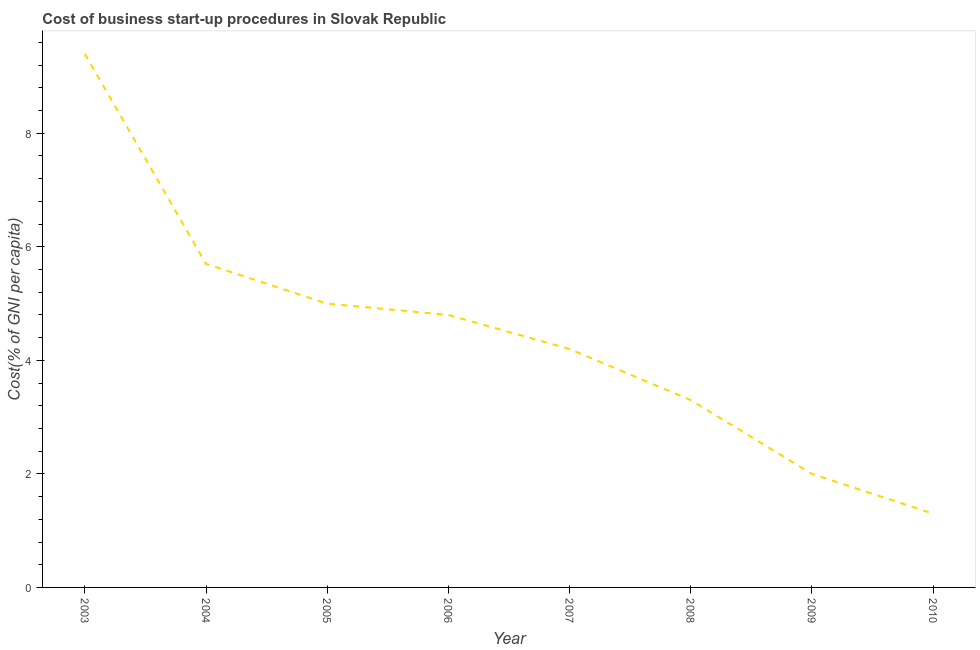What is the cost of business startup procedures in 2005?
Provide a short and direct response. 5. Across all years, what is the maximum cost of business startup procedures?
Give a very brief answer. 9.4. What is the sum of the cost of business startup procedures?
Keep it short and to the point. 35.7. What is the difference between the cost of business startup procedures in 2003 and 2008?
Your answer should be compact. 6.1. What is the average cost of business startup procedures per year?
Ensure brevity in your answer.  4.46. Do a majority of the years between 2009 and 2006 (inclusive) have cost of business startup procedures greater than 6 %?
Your response must be concise. Yes. What is the ratio of the cost of business startup procedures in 2005 to that in 2007?
Your response must be concise. 1.19. What is the difference between the highest and the lowest cost of business startup procedures?
Give a very brief answer. 8.1. How many lines are there?
Keep it short and to the point. 1. What is the title of the graph?
Provide a succinct answer. Cost of business start-up procedures in Slovak Republic. What is the label or title of the Y-axis?
Ensure brevity in your answer.  Cost(% of GNI per capita). What is the Cost(% of GNI per capita) of 2003?
Provide a short and direct response. 9.4. What is the Cost(% of GNI per capita) of 2009?
Provide a succinct answer. 2. What is the Cost(% of GNI per capita) of 2010?
Offer a very short reply. 1.3. What is the difference between the Cost(% of GNI per capita) in 2003 and 2006?
Your response must be concise. 4.6. What is the difference between the Cost(% of GNI per capita) in 2003 and 2007?
Provide a short and direct response. 5.2. What is the difference between the Cost(% of GNI per capita) in 2003 and 2010?
Provide a short and direct response. 8.1. What is the difference between the Cost(% of GNI per capita) in 2004 and 2005?
Offer a very short reply. 0.7. What is the difference between the Cost(% of GNI per capita) in 2004 and 2008?
Ensure brevity in your answer.  2.4. What is the difference between the Cost(% of GNI per capita) in 2005 and 2006?
Keep it short and to the point. 0.2. What is the difference between the Cost(% of GNI per capita) in 2005 and 2008?
Your answer should be compact. 1.7. What is the difference between the Cost(% of GNI per capita) in 2006 and 2009?
Offer a terse response. 2.8. What is the difference between the Cost(% of GNI per capita) in 2007 and 2008?
Give a very brief answer. 0.9. What is the difference between the Cost(% of GNI per capita) in 2007 and 2009?
Offer a very short reply. 2.2. What is the difference between the Cost(% of GNI per capita) in 2009 and 2010?
Provide a succinct answer. 0.7. What is the ratio of the Cost(% of GNI per capita) in 2003 to that in 2004?
Make the answer very short. 1.65. What is the ratio of the Cost(% of GNI per capita) in 2003 to that in 2005?
Provide a succinct answer. 1.88. What is the ratio of the Cost(% of GNI per capita) in 2003 to that in 2006?
Give a very brief answer. 1.96. What is the ratio of the Cost(% of GNI per capita) in 2003 to that in 2007?
Your answer should be compact. 2.24. What is the ratio of the Cost(% of GNI per capita) in 2003 to that in 2008?
Keep it short and to the point. 2.85. What is the ratio of the Cost(% of GNI per capita) in 2003 to that in 2010?
Make the answer very short. 7.23. What is the ratio of the Cost(% of GNI per capita) in 2004 to that in 2005?
Keep it short and to the point. 1.14. What is the ratio of the Cost(% of GNI per capita) in 2004 to that in 2006?
Make the answer very short. 1.19. What is the ratio of the Cost(% of GNI per capita) in 2004 to that in 2007?
Make the answer very short. 1.36. What is the ratio of the Cost(% of GNI per capita) in 2004 to that in 2008?
Offer a very short reply. 1.73. What is the ratio of the Cost(% of GNI per capita) in 2004 to that in 2009?
Your response must be concise. 2.85. What is the ratio of the Cost(% of GNI per capita) in 2004 to that in 2010?
Provide a short and direct response. 4.38. What is the ratio of the Cost(% of GNI per capita) in 2005 to that in 2006?
Give a very brief answer. 1.04. What is the ratio of the Cost(% of GNI per capita) in 2005 to that in 2007?
Give a very brief answer. 1.19. What is the ratio of the Cost(% of GNI per capita) in 2005 to that in 2008?
Give a very brief answer. 1.51. What is the ratio of the Cost(% of GNI per capita) in 2005 to that in 2009?
Your answer should be compact. 2.5. What is the ratio of the Cost(% of GNI per capita) in 2005 to that in 2010?
Provide a succinct answer. 3.85. What is the ratio of the Cost(% of GNI per capita) in 2006 to that in 2007?
Ensure brevity in your answer.  1.14. What is the ratio of the Cost(% of GNI per capita) in 2006 to that in 2008?
Ensure brevity in your answer.  1.46. What is the ratio of the Cost(% of GNI per capita) in 2006 to that in 2010?
Your answer should be very brief. 3.69. What is the ratio of the Cost(% of GNI per capita) in 2007 to that in 2008?
Your response must be concise. 1.27. What is the ratio of the Cost(% of GNI per capita) in 2007 to that in 2009?
Give a very brief answer. 2.1. What is the ratio of the Cost(% of GNI per capita) in 2007 to that in 2010?
Keep it short and to the point. 3.23. What is the ratio of the Cost(% of GNI per capita) in 2008 to that in 2009?
Your response must be concise. 1.65. What is the ratio of the Cost(% of GNI per capita) in 2008 to that in 2010?
Make the answer very short. 2.54. What is the ratio of the Cost(% of GNI per capita) in 2009 to that in 2010?
Provide a short and direct response. 1.54. 